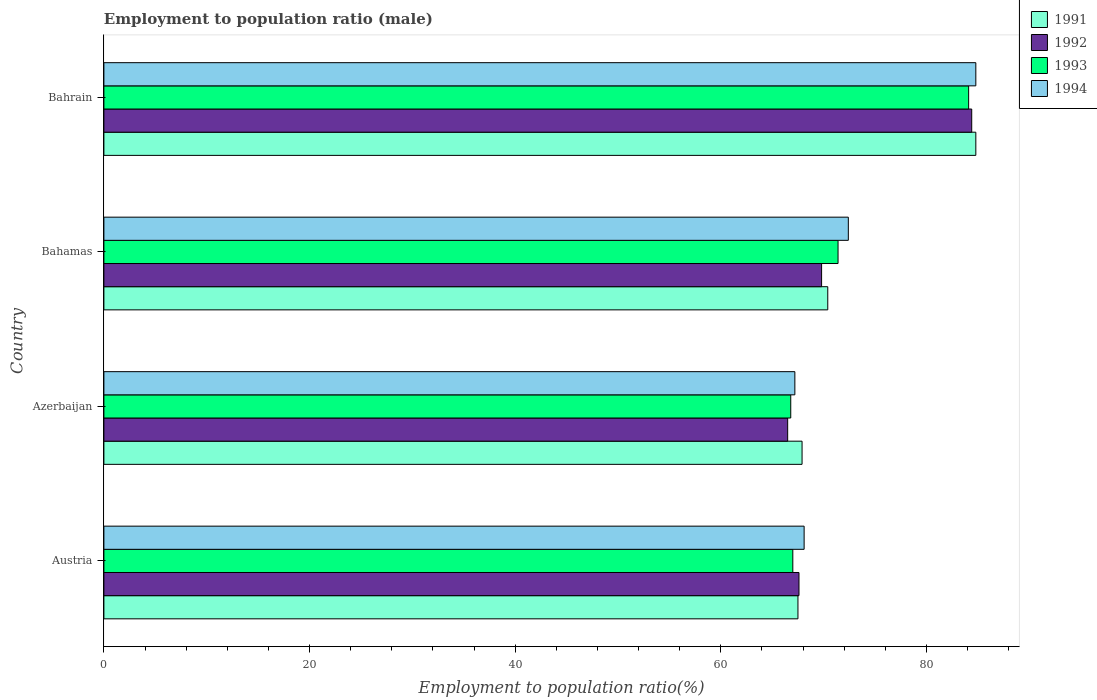How many different coloured bars are there?
Offer a terse response. 4. Are the number of bars per tick equal to the number of legend labels?
Provide a short and direct response. Yes. Are the number of bars on each tick of the Y-axis equal?
Keep it short and to the point. Yes. How many bars are there on the 1st tick from the bottom?
Give a very brief answer. 4. What is the label of the 1st group of bars from the top?
Make the answer very short. Bahrain. In how many cases, is the number of bars for a given country not equal to the number of legend labels?
Keep it short and to the point. 0. What is the employment to population ratio in 1992 in Azerbaijan?
Your response must be concise. 66.5. Across all countries, what is the maximum employment to population ratio in 1991?
Your answer should be compact. 84.8. Across all countries, what is the minimum employment to population ratio in 1991?
Your answer should be compact. 67.5. In which country was the employment to population ratio in 1991 maximum?
Offer a terse response. Bahrain. What is the total employment to population ratio in 1993 in the graph?
Give a very brief answer. 289.3. What is the difference between the employment to population ratio in 1994 in Azerbaijan and that in Bahamas?
Offer a terse response. -5.2. What is the difference between the employment to population ratio in 1993 in Austria and the employment to population ratio in 1991 in Bahamas?
Make the answer very short. -3.4. What is the average employment to population ratio in 1993 per country?
Your answer should be very brief. 72.33. In how many countries, is the employment to population ratio in 1994 greater than 56 %?
Give a very brief answer. 4. What is the ratio of the employment to population ratio in 1993 in Azerbaijan to that in Bahamas?
Your answer should be very brief. 0.94. Is the employment to population ratio in 1994 in Azerbaijan less than that in Bahamas?
Make the answer very short. Yes. Is the difference between the employment to population ratio in 1992 in Austria and Bahamas greater than the difference between the employment to population ratio in 1994 in Austria and Bahamas?
Provide a short and direct response. Yes. What is the difference between the highest and the second highest employment to population ratio in 1994?
Keep it short and to the point. 12.4. What is the difference between the highest and the lowest employment to population ratio in 1992?
Make the answer very short. 17.9. In how many countries, is the employment to population ratio in 1994 greater than the average employment to population ratio in 1994 taken over all countries?
Your answer should be compact. 1. Is the sum of the employment to population ratio in 1991 in Bahamas and Bahrain greater than the maximum employment to population ratio in 1992 across all countries?
Your answer should be compact. Yes. What does the 3rd bar from the top in Bahrain represents?
Keep it short and to the point. 1992. What does the 1st bar from the bottom in Bahamas represents?
Your answer should be compact. 1991. Is it the case that in every country, the sum of the employment to population ratio in 1992 and employment to population ratio in 1994 is greater than the employment to population ratio in 1991?
Offer a very short reply. Yes. How many bars are there?
Your answer should be compact. 16. How many countries are there in the graph?
Provide a succinct answer. 4. Does the graph contain any zero values?
Your answer should be compact. No. How many legend labels are there?
Your response must be concise. 4. How are the legend labels stacked?
Your response must be concise. Vertical. What is the title of the graph?
Make the answer very short. Employment to population ratio (male). Does "2001" appear as one of the legend labels in the graph?
Provide a short and direct response. No. What is the label or title of the X-axis?
Ensure brevity in your answer.  Employment to population ratio(%). What is the Employment to population ratio(%) of 1991 in Austria?
Offer a terse response. 67.5. What is the Employment to population ratio(%) of 1992 in Austria?
Your answer should be very brief. 67.6. What is the Employment to population ratio(%) in 1993 in Austria?
Provide a succinct answer. 67. What is the Employment to population ratio(%) of 1994 in Austria?
Give a very brief answer. 68.1. What is the Employment to population ratio(%) in 1991 in Azerbaijan?
Provide a succinct answer. 67.9. What is the Employment to population ratio(%) in 1992 in Azerbaijan?
Ensure brevity in your answer.  66.5. What is the Employment to population ratio(%) of 1993 in Azerbaijan?
Keep it short and to the point. 66.8. What is the Employment to population ratio(%) of 1994 in Azerbaijan?
Give a very brief answer. 67.2. What is the Employment to population ratio(%) of 1991 in Bahamas?
Your answer should be compact. 70.4. What is the Employment to population ratio(%) in 1992 in Bahamas?
Give a very brief answer. 69.8. What is the Employment to population ratio(%) in 1993 in Bahamas?
Offer a terse response. 71.4. What is the Employment to population ratio(%) of 1994 in Bahamas?
Ensure brevity in your answer.  72.4. What is the Employment to population ratio(%) of 1991 in Bahrain?
Your answer should be very brief. 84.8. What is the Employment to population ratio(%) in 1992 in Bahrain?
Provide a short and direct response. 84.4. What is the Employment to population ratio(%) of 1993 in Bahrain?
Ensure brevity in your answer.  84.1. What is the Employment to population ratio(%) in 1994 in Bahrain?
Provide a succinct answer. 84.8. Across all countries, what is the maximum Employment to population ratio(%) in 1991?
Keep it short and to the point. 84.8. Across all countries, what is the maximum Employment to population ratio(%) in 1992?
Provide a short and direct response. 84.4. Across all countries, what is the maximum Employment to population ratio(%) of 1993?
Offer a very short reply. 84.1. Across all countries, what is the maximum Employment to population ratio(%) in 1994?
Your answer should be very brief. 84.8. Across all countries, what is the minimum Employment to population ratio(%) in 1991?
Give a very brief answer. 67.5. Across all countries, what is the minimum Employment to population ratio(%) in 1992?
Your answer should be very brief. 66.5. Across all countries, what is the minimum Employment to population ratio(%) of 1993?
Offer a terse response. 66.8. Across all countries, what is the minimum Employment to population ratio(%) in 1994?
Give a very brief answer. 67.2. What is the total Employment to population ratio(%) in 1991 in the graph?
Make the answer very short. 290.6. What is the total Employment to population ratio(%) of 1992 in the graph?
Offer a very short reply. 288.3. What is the total Employment to population ratio(%) in 1993 in the graph?
Keep it short and to the point. 289.3. What is the total Employment to population ratio(%) in 1994 in the graph?
Your response must be concise. 292.5. What is the difference between the Employment to population ratio(%) of 1992 in Austria and that in Azerbaijan?
Keep it short and to the point. 1.1. What is the difference between the Employment to population ratio(%) in 1993 in Austria and that in Azerbaijan?
Keep it short and to the point. 0.2. What is the difference between the Employment to population ratio(%) in 1991 in Austria and that in Bahamas?
Your answer should be compact. -2.9. What is the difference between the Employment to population ratio(%) of 1992 in Austria and that in Bahamas?
Keep it short and to the point. -2.2. What is the difference between the Employment to population ratio(%) of 1993 in Austria and that in Bahamas?
Give a very brief answer. -4.4. What is the difference between the Employment to population ratio(%) of 1991 in Austria and that in Bahrain?
Keep it short and to the point. -17.3. What is the difference between the Employment to population ratio(%) in 1992 in Austria and that in Bahrain?
Keep it short and to the point. -16.8. What is the difference between the Employment to population ratio(%) of 1993 in Austria and that in Bahrain?
Provide a short and direct response. -17.1. What is the difference between the Employment to population ratio(%) in 1994 in Austria and that in Bahrain?
Give a very brief answer. -16.7. What is the difference between the Employment to population ratio(%) of 1992 in Azerbaijan and that in Bahamas?
Give a very brief answer. -3.3. What is the difference between the Employment to population ratio(%) of 1994 in Azerbaijan and that in Bahamas?
Your response must be concise. -5.2. What is the difference between the Employment to population ratio(%) in 1991 in Azerbaijan and that in Bahrain?
Offer a very short reply. -16.9. What is the difference between the Employment to population ratio(%) in 1992 in Azerbaijan and that in Bahrain?
Your answer should be compact. -17.9. What is the difference between the Employment to population ratio(%) in 1993 in Azerbaijan and that in Bahrain?
Provide a succinct answer. -17.3. What is the difference between the Employment to population ratio(%) in 1994 in Azerbaijan and that in Bahrain?
Provide a short and direct response. -17.6. What is the difference between the Employment to population ratio(%) in 1991 in Bahamas and that in Bahrain?
Keep it short and to the point. -14.4. What is the difference between the Employment to population ratio(%) of 1992 in Bahamas and that in Bahrain?
Your answer should be very brief. -14.6. What is the difference between the Employment to population ratio(%) of 1994 in Bahamas and that in Bahrain?
Provide a short and direct response. -12.4. What is the difference between the Employment to population ratio(%) in 1991 in Austria and the Employment to population ratio(%) in 1992 in Azerbaijan?
Your response must be concise. 1. What is the difference between the Employment to population ratio(%) in 1991 in Austria and the Employment to population ratio(%) in 1993 in Azerbaijan?
Offer a terse response. 0.7. What is the difference between the Employment to population ratio(%) in 1991 in Austria and the Employment to population ratio(%) in 1993 in Bahamas?
Make the answer very short. -3.9. What is the difference between the Employment to population ratio(%) of 1991 in Austria and the Employment to population ratio(%) of 1994 in Bahamas?
Give a very brief answer. -4.9. What is the difference between the Employment to population ratio(%) of 1991 in Austria and the Employment to population ratio(%) of 1992 in Bahrain?
Your answer should be very brief. -16.9. What is the difference between the Employment to population ratio(%) in 1991 in Austria and the Employment to population ratio(%) in 1993 in Bahrain?
Your response must be concise. -16.6. What is the difference between the Employment to population ratio(%) of 1991 in Austria and the Employment to population ratio(%) of 1994 in Bahrain?
Make the answer very short. -17.3. What is the difference between the Employment to population ratio(%) in 1992 in Austria and the Employment to population ratio(%) in 1993 in Bahrain?
Your answer should be compact. -16.5. What is the difference between the Employment to population ratio(%) in 1992 in Austria and the Employment to population ratio(%) in 1994 in Bahrain?
Offer a terse response. -17.2. What is the difference between the Employment to population ratio(%) in 1993 in Austria and the Employment to population ratio(%) in 1994 in Bahrain?
Offer a very short reply. -17.8. What is the difference between the Employment to population ratio(%) in 1992 in Azerbaijan and the Employment to population ratio(%) in 1993 in Bahamas?
Provide a short and direct response. -4.9. What is the difference between the Employment to population ratio(%) in 1991 in Azerbaijan and the Employment to population ratio(%) in 1992 in Bahrain?
Provide a succinct answer. -16.5. What is the difference between the Employment to population ratio(%) of 1991 in Azerbaijan and the Employment to population ratio(%) of 1993 in Bahrain?
Your response must be concise. -16.2. What is the difference between the Employment to population ratio(%) in 1991 in Azerbaijan and the Employment to population ratio(%) in 1994 in Bahrain?
Give a very brief answer. -16.9. What is the difference between the Employment to population ratio(%) of 1992 in Azerbaijan and the Employment to population ratio(%) of 1993 in Bahrain?
Your answer should be compact. -17.6. What is the difference between the Employment to population ratio(%) in 1992 in Azerbaijan and the Employment to population ratio(%) in 1994 in Bahrain?
Your response must be concise. -18.3. What is the difference between the Employment to population ratio(%) of 1993 in Azerbaijan and the Employment to population ratio(%) of 1994 in Bahrain?
Keep it short and to the point. -18. What is the difference between the Employment to population ratio(%) in 1991 in Bahamas and the Employment to population ratio(%) in 1992 in Bahrain?
Ensure brevity in your answer.  -14. What is the difference between the Employment to population ratio(%) in 1991 in Bahamas and the Employment to population ratio(%) in 1993 in Bahrain?
Offer a very short reply. -13.7. What is the difference between the Employment to population ratio(%) in 1991 in Bahamas and the Employment to population ratio(%) in 1994 in Bahrain?
Your answer should be compact. -14.4. What is the difference between the Employment to population ratio(%) in 1992 in Bahamas and the Employment to population ratio(%) in 1993 in Bahrain?
Make the answer very short. -14.3. What is the difference between the Employment to population ratio(%) in 1992 in Bahamas and the Employment to population ratio(%) in 1994 in Bahrain?
Offer a very short reply. -15. What is the average Employment to population ratio(%) in 1991 per country?
Your answer should be very brief. 72.65. What is the average Employment to population ratio(%) in 1992 per country?
Provide a short and direct response. 72.08. What is the average Employment to population ratio(%) in 1993 per country?
Make the answer very short. 72.33. What is the average Employment to population ratio(%) of 1994 per country?
Ensure brevity in your answer.  73.12. What is the difference between the Employment to population ratio(%) of 1991 and Employment to population ratio(%) of 1994 in Austria?
Offer a very short reply. -0.6. What is the difference between the Employment to population ratio(%) of 1992 and Employment to population ratio(%) of 1994 in Austria?
Your answer should be compact. -0.5. What is the difference between the Employment to population ratio(%) in 1991 and Employment to population ratio(%) in 1993 in Azerbaijan?
Provide a succinct answer. 1.1. What is the difference between the Employment to population ratio(%) of 1992 and Employment to population ratio(%) of 1993 in Azerbaijan?
Provide a succinct answer. -0.3. What is the difference between the Employment to population ratio(%) of 1992 and Employment to population ratio(%) of 1994 in Azerbaijan?
Offer a terse response. -0.7. What is the difference between the Employment to population ratio(%) of 1991 and Employment to population ratio(%) of 1992 in Bahamas?
Your answer should be compact. 0.6. What is the difference between the Employment to population ratio(%) of 1991 and Employment to population ratio(%) of 1994 in Bahamas?
Offer a terse response. -2. What is the difference between the Employment to population ratio(%) of 1991 and Employment to population ratio(%) of 1993 in Bahrain?
Keep it short and to the point. 0.7. What is the difference between the Employment to population ratio(%) of 1992 and Employment to population ratio(%) of 1993 in Bahrain?
Provide a short and direct response. 0.3. What is the difference between the Employment to population ratio(%) of 1992 and Employment to population ratio(%) of 1994 in Bahrain?
Offer a very short reply. -0.4. What is the difference between the Employment to population ratio(%) in 1993 and Employment to population ratio(%) in 1994 in Bahrain?
Offer a terse response. -0.7. What is the ratio of the Employment to population ratio(%) of 1991 in Austria to that in Azerbaijan?
Your answer should be compact. 0.99. What is the ratio of the Employment to population ratio(%) of 1992 in Austria to that in Azerbaijan?
Offer a very short reply. 1.02. What is the ratio of the Employment to population ratio(%) in 1993 in Austria to that in Azerbaijan?
Your answer should be very brief. 1. What is the ratio of the Employment to population ratio(%) of 1994 in Austria to that in Azerbaijan?
Ensure brevity in your answer.  1.01. What is the ratio of the Employment to population ratio(%) of 1991 in Austria to that in Bahamas?
Your answer should be compact. 0.96. What is the ratio of the Employment to population ratio(%) in 1992 in Austria to that in Bahamas?
Keep it short and to the point. 0.97. What is the ratio of the Employment to population ratio(%) of 1993 in Austria to that in Bahamas?
Give a very brief answer. 0.94. What is the ratio of the Employment to population ratio(%) in 1994 in Austria to that in Bahamas?
Offer a terse response. 0.94. What is the ratio of the Employment to population ratio(%) in 1991 in Austria to that in Bahrain?
Keep it short and to the point. 0.8. What is the ratio of the Employment to population ratio(%) of 1992 in Austria to that in Bahrain?
Provide a succinct answer. 0.8. What is the ratio of the Employment to population ratio(%) in 1993 in Austria to that in Bahrain?
Your answer should be very brief. 0.8. What is the ratio of the Employment to population ratio(%) in 1994 in Austria to that in Bahrain?
Keep it short and to the point. 0.8. What is the ratio of the Employment to population ratio(%) of 1991 in Azerbaijan to that in Bahamas?
Your answer should be very brief. 0.96. What is the ratio of the Employment to population ratio(%) in 1992 in Azerbaijan to that in Bahamas?
Give a very brief answer. 0.95. What is the ratio of the Employment to population ratio(%) in 1993 in Azerbaijan to that in Bahamas?
Your response must be concise. 0.94. What is the ratio of the Employment to population ratio(%) of 1994 in Azerbaijan to that in Bahamas?
Offer a terse response. 0.93. What is the ratio of the Employment to population ratio(%) in 1991 in Azerbaijan to that in Bahrain?
Your answer should be very brief. 0.8. What is the ratio of the Employment to population ratio(%) in 1992 in Azerbaijan to that in Bahrain?
Keep it short and to the point. 0.79. What is the ratio of the Employment to population ratio(%) in 1993 in Azerbaijan to that in Bahrain?
Provide a succinct answer. 0.79. What is the ratio of the Employment to population ratio(%) in 1994 in Azerbaijan to that in Bahrain?
Provide a short and direct response. 0.79. What is the ratio of the Employment to population ratio(%) in 1991 in Bahamas to that in Bahrain?
Provide a succinct answer. 0.83. What is the ratio of the Employment to population ratio(%) of 1992 in Bahamas to that in Bahrain?
Your response must be concise. 0.83. What is the ratio of the Employment to population ratio(%) of 1993 in Bahamas to that in Bahrain?
Provide a short and direct response. 0.85. What is the ratio of the Employment to population ratio(%) of 1994 in Bahamas to that in Bahrain?
Give a very brief answer. 0.85. What is the difference between the highest and the second highest Employment to population ratio(%) of 1991?
Your answer should be very brief. 14.4. What is the difference between the highest and the second highest Employment to population ratio(%) of 1993?
Offer a very short reply. 12.7. What is the difference between the highest and the second highest Employment to population ratio(%) of 1994?
Your response must be concise. 12.4. What is the difference between the highest and the lowest Employment to population ratio(%) in 1991?
Your answer should be compact. 17.3. What is the difference between the highest and the lowest Employment to population ratio(%) of 1992?
Offer a terse response. 17.9. What is the difference between the highest and the lowest Employment to population ratio(%) of 1993?
Ensure brevity in your answer.  17.3. What is the difference between the highest and the lowest Employment to population ratio(%) in 1994?
Make the answer very short. 17.6. 